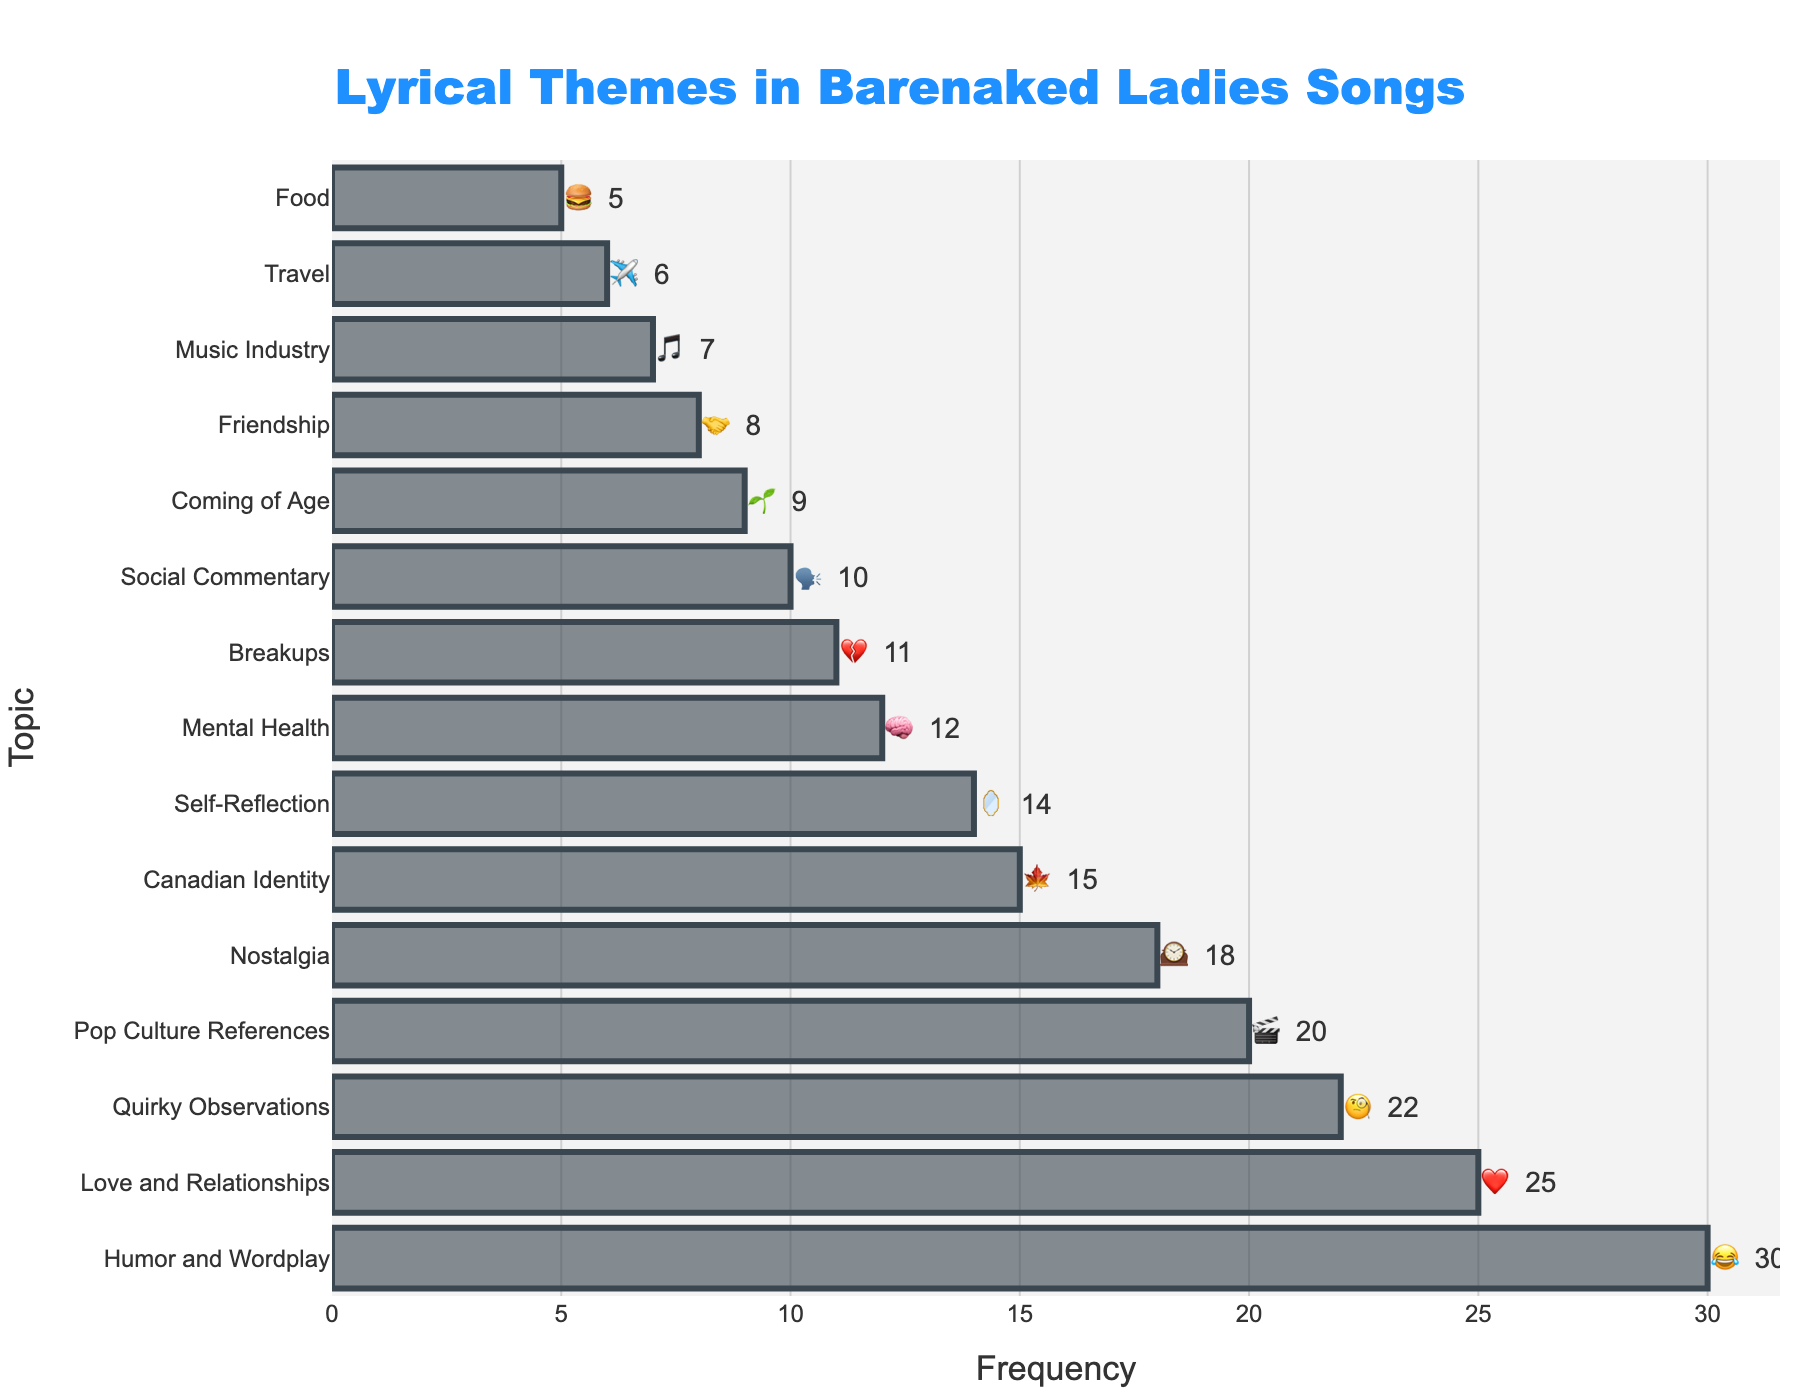1. What is the title of the chart? The title is displayed at the top center of the chart. It reads: "Lyrical Themes in Barenaked Ladies Songs"
Answer: Lyrical Themes in Barenaked Ladies Songs 2. Which topic has the highest frequency? By looking at the bar lengths, the topic with the longest bar represents the highest frequency. "Humor and Wordplay" has the highest frequency.
Answer: Humor and Wordplay 3. How many topics have a frequency greater than 20? Count the number of bars with a frequency greater than 20. These topics are "Humor and Wordplay" (30), "Quirky Observations" (22), and "Love and Relationships" (25), making a total of 3 topics.
Answer: 3 4. What is the combined frequency of "Love and Relationships" and "Breakups"? Add the frequencies of "Love and Relationships" and "Breakups": 25 (Love and Relationships) + 11 (Breakups) = 36
Answer: 36 5. Which topic represented by an emoji deals with nostalgia? The emoji associated with "Nostalgia" is 🕰️.
Answer: 🕰️ 6. Is the frequency of "Travel" higher, lower, or equal to "Food"? Compare the frequencies of "Travel" (6) and "Food" (5). 6 is greater than 5, so "Travel" has a higher frequency than "Food."
Answer: Higher 7. What is the frequency difference between "Social Commentary" and "Friendship"? Subtract the frequency of "Friendship" from "Social Commentary": 10 (Social Commentary) - 8 (Friendship) = 2
Answer: 2 8. Which topic is represented with the emoji 🎬? By looking at the emojis, the one associated with 🎬 is "Pop Culture References".
Answer: Pop Culture References 9. How many topics have a frequency less than 10? Count the number of bars with a frequency less than 10. These topics are "Travel" (6), "Food" (5), "Music Industry" (7), "Friendship" (8), and "Coming of Age" (9), making a total of 5 topics.
Answer: 5 